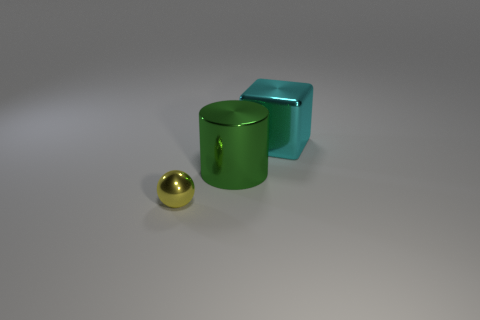Add 2 big brown balls. How many objects exist? 5 Subtract all spheres. How many objects are left? 2 Add 2 green cylinders. How many green cylinders are left? 3 Add 1 shiny cylinders. How many shiny cylinders exist? 2 Subtract 0 gray cylinders. How many objects are left? 3 Subtract all metal cubes. Subtract all big cyan metallic cubes. How many objects are left? 1 